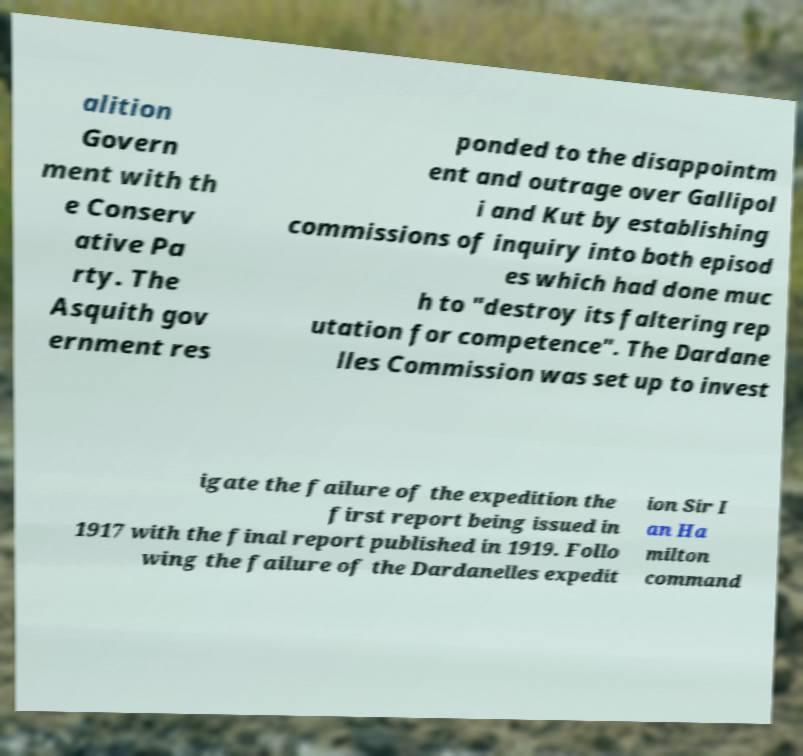Please identify and transcribe the text found in this image. alition Govern ment with th e Conserv ative Pa rty. The Asquith gov ernment res ponded to the disappointm ent and outrage over Gallipol i and Kut by establishing commissions of inquiry into both episod es which had done muc h to "destroy its faltering rep utation for competence". The Dardane lles Commission was set up to invest igate the failure of the expedition the first report being issued in 1917 with the final report published in 1919. Follo wing the failure of the Dardanelles expedit ion Sir I an Ha milton command 